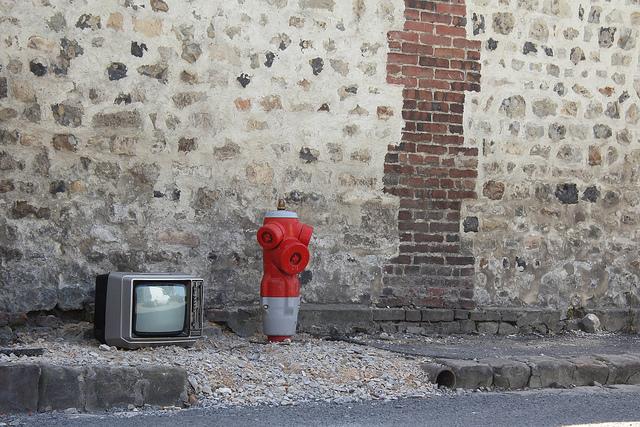What is next to the hydrant?
Give a very brief answer. Tv. What color is the hydrant?
Short answer required. Red. Are those the original bricks on the wall?
Quick response, please. No. 